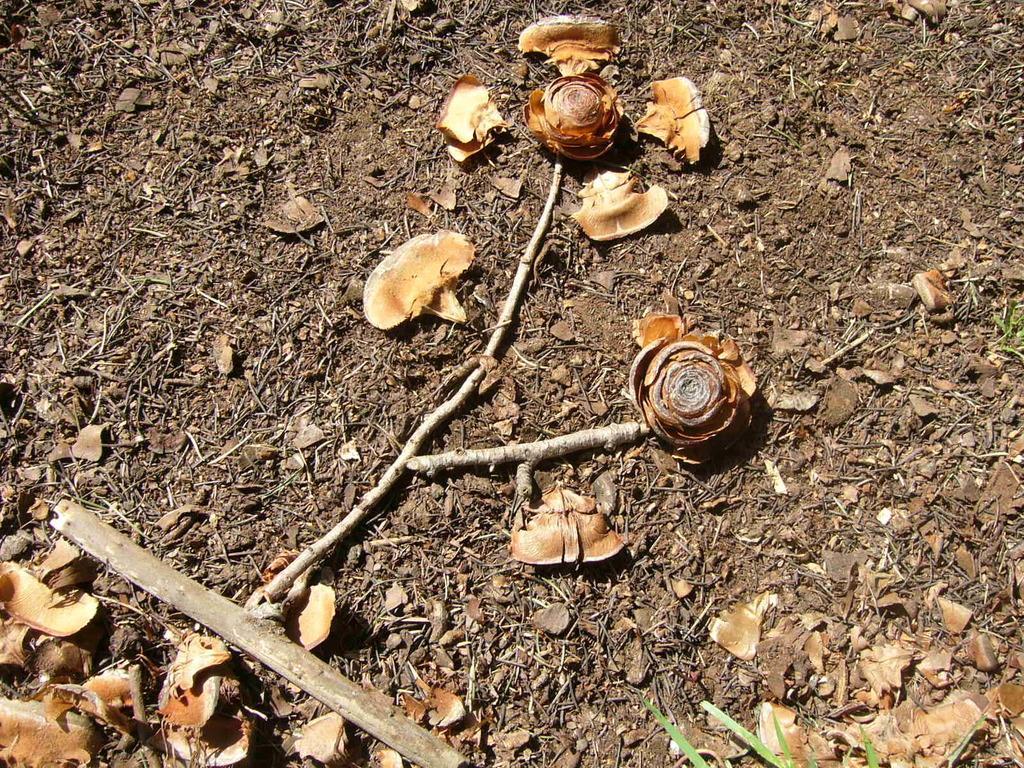Can you describe this image briefly? In this image we can see some shells, dried leaves and stems which are placed on the dried land. 